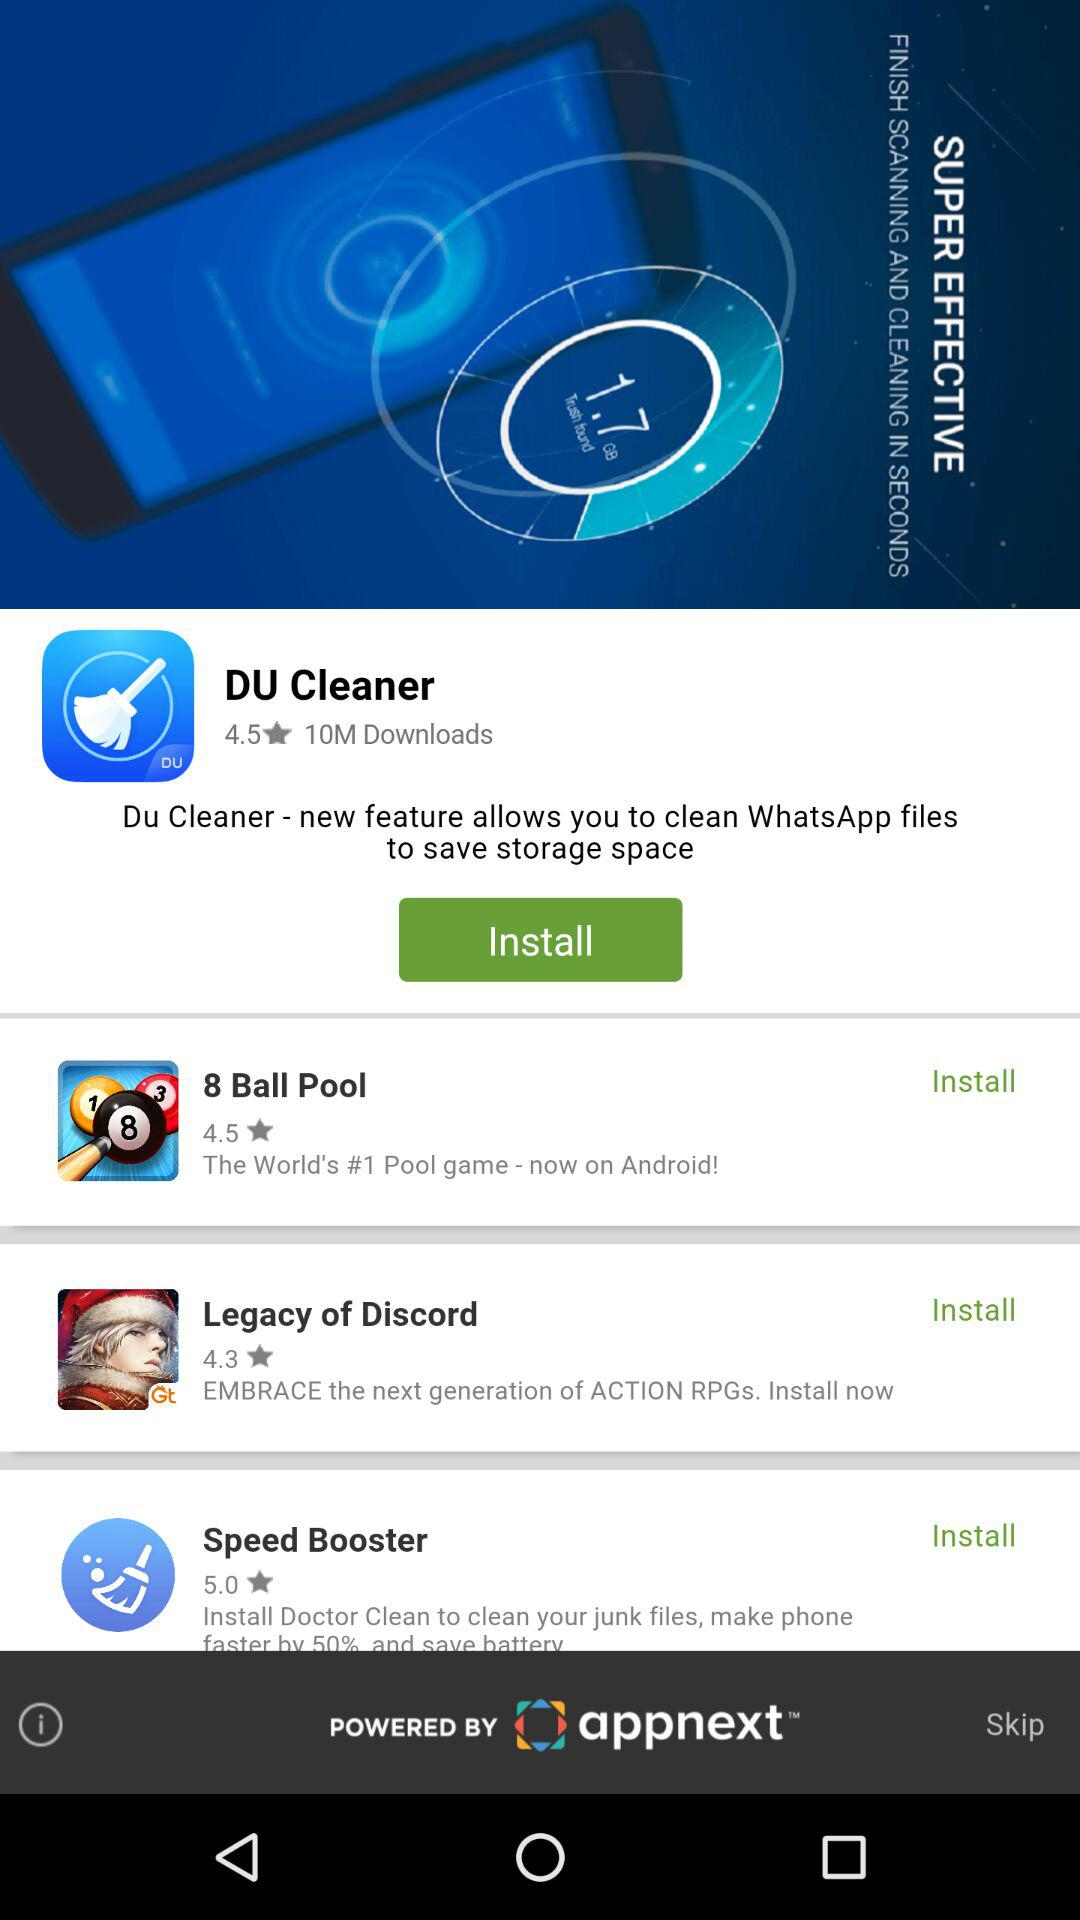What is the rating of DU cleaner? The rating is 4.5 stars. 